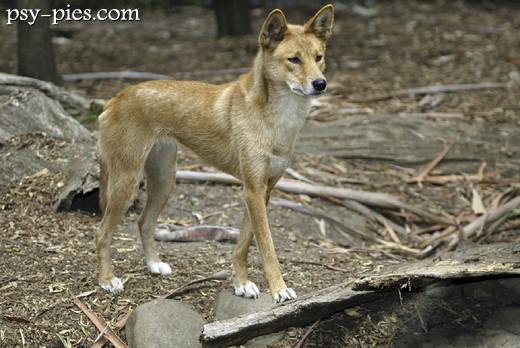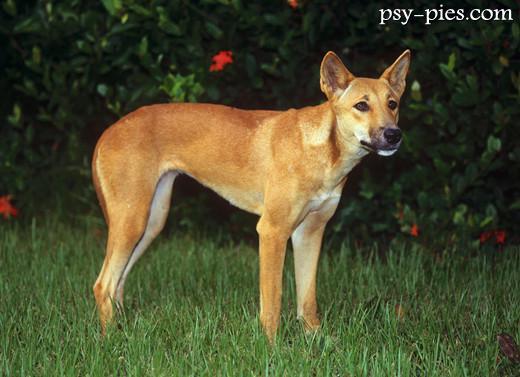The first image is the image on the left, the second image is the image on the right. Analyze the images presented: Is the assertion "There are at most two dingoes." valid? Answer yes or no. Yes. The first image is the image on the left, the second image is the image on the right. Considering the images on both sides, is "The wild dog in the image on the right is lying down outside." valid? Answer yes or no. No. 